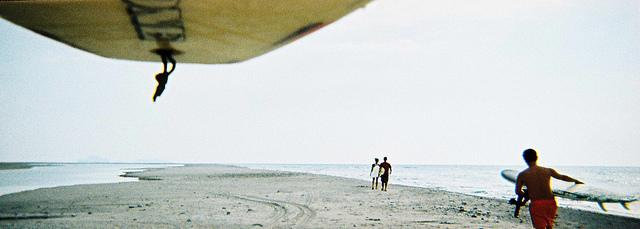How will the people here likely propel themselves upon waves? surfboards 